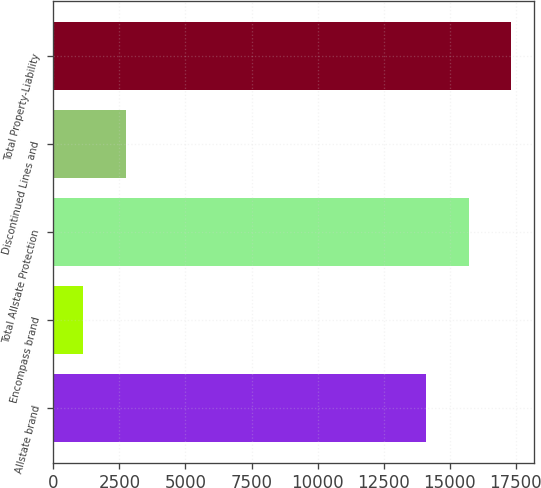Convert chart to OTSL. <chart><loc_0><loc_0><loc_500><loc_500><bar_chart><fcel>Allstate brand<fcel>Encompass brand<fcel>Total Allstate Protection<fcel>Discontinued Lines and<fcel>Total Property-Liability<nl><fcel>14118<fcel>1133<fcel>15722.9<fcel>2737.9<fcel>17327.8<nl></chart> 